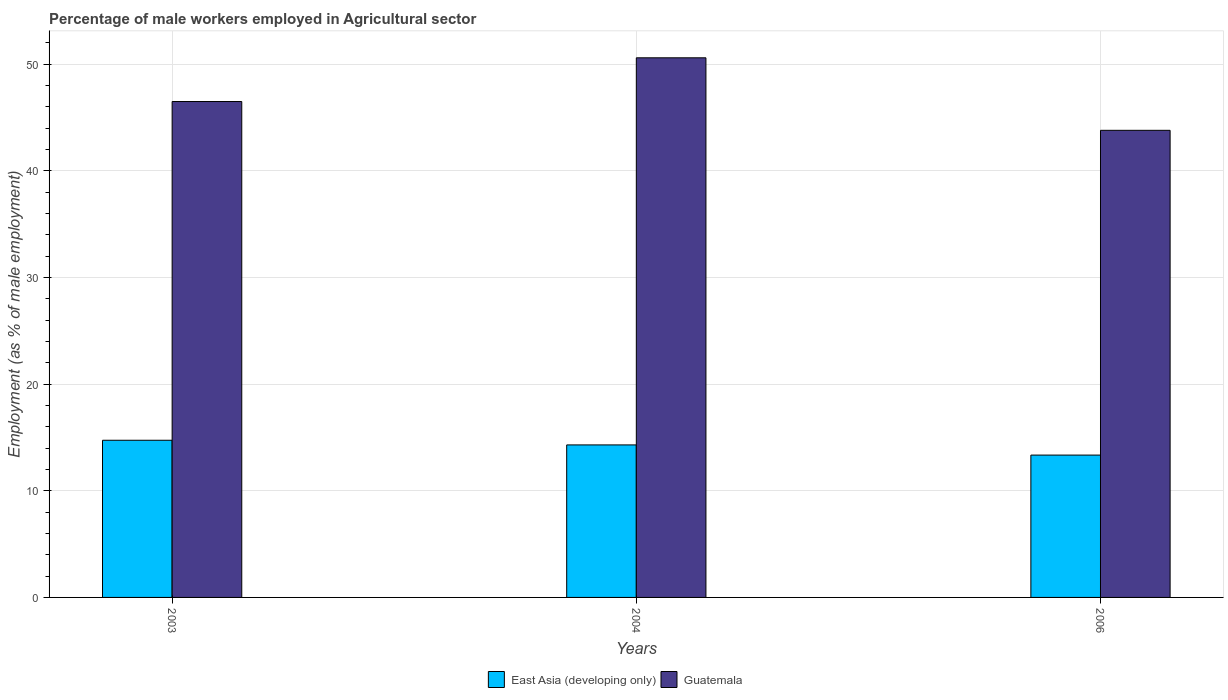How many bars are there on the 1st tick from the right?
Make the answer very short. 2. In how many cases, is the number of bars for a given year not equal to the number of legend labels?
Ensure brevity in your answer.  0. What is the percentage of male workers employed in Agricultural sector in Guatemala in 2003?
Ensure brevity in your answer.  46.5. Across all years, what is the maximum percentage of male workers employed in Agricultural sector in Guatemala?
Give a very brief answer. 50.6. Across all years, what is the minimum percentage of male workers employed in Agricultural sector in Guatemala?
Your answer should be very brief. 43.8. In which year was the percentage of male workers employed in Agricultural sector in Guatemala minimum?
Your answer should be compact. 2006. What is the total percentage of male workers employed in Agricultural sector in East Asia (developing only) in the graph?
Offer a very short reply. 42.39. What is the difference between the percentage of male workers employed in Agricultural sector in Guatemala in 2004 and that in 2006?
Provide a succinct answer. 6.8. What is the difference between the percentage of male workers employed in Agricultural sector in Guatemala in 2003 and the percentage of male workers employed in Agricultural sector in East Asia (developing only) in 2006?
Your response must be concise. 33.15. What is the average percentage of male workers employed in Agricultural sector in Guatemala per year?
Make the answer very short. 46.97. In the year 2006, what is the difference between the percentage of male workers employed in Agricultural sector in East Asia (developing only) and percentage of male workers employed in Agricultural sector in Guatemala?
Give a very brief answer. -30.45. What is the ratio of the percentage of male workers employed in Agricultural sector in East Asia (developing only) in 2003 to that in 2004?
Provide a succinct answer. 1.03. What is the difference between the highest and the second highest percentage of male workers employed in Agricultural sector in East Asia (developing only)?
Your response must be concise. 0.44. What is the difference between the highest and the lowest percentage of male workers employed in Agricultural sector in Guatemala?
Give a very brief answer. 6.8. In how many years, is the percentage of male workers employed in Agricultural sector in East Asia (developing only) greater than the average percentage of male workers employed in Agricultural sector in East Asia (developing only) taken over all years?
Give a very brief answer. 2. Is the sum of the percentage of male workers employed in Agricultural sector in East Asia (developing only) in 2004 and 2006 greater than the maximum percentage of male workers employed in Agricultural sector in Guatemala across all years?
Your answer should be very brief. No. What does the 2nd bar from the left in 2006 represents?
Keep it short and to the point. Guatemala. What does the 1st bar from the right in 2006 represents?
Your answer should be very brief. Guatemala. How many years are there in the graph?
Ensure brevity in your answer.  3. What is the difference between two consecutive major ticks on the Y-axis?
Offer a terse response. 10. Does the graph contain grids?
Ensure brevity in your answer.  Yes. How are the legend labels stacked?
Your answer should be compact. Horizontal. What is the title of the graph?
Keep it short and to the point. Percentage of male workers employed in Agricultural sector. Does "Nigeria" appear as one of the legend labels in the graph?
Your response must be concise. No. What is the label or title of the X-axis?
Provide a short and direct response. Years. What is the label or title of the Y-axis?
Make the answer very short. Employment (as % of male employment). What is the Employment (as % of male employment) in East Asia (developing only) in 2003?
Give a very brief answer. 14.74. What is the Employment (as % of male employment) in Guatemala in 2003?
Ensure brevity in your answer.  46.5. What is the Employment (as % of male employment) in East Asia (developing only) in 2004?
Offer a very short reply. 14.3. What is the Employment (as % of male employment) of Guatemala in 2004?
Your answer should be very brief. 50.6. What is the Employment (as % of male employment) in East Asia (developing only) in 2006?
Make the answer very short. 13.35. What is the Employment (as % of male employment) in Guatemala in 2006?
Give a very brief answer. 43.8. Across all years, what is the maximum Employment (as % of male employment) in East Asia (developing only)?
Your answer should be compact. 14.74. Across all years, what is the maximum Employment (as % of male employment) in Guatemala?
Provide a short and direct response. 50.6. Across all years, what is the minimum Employment (as % of male employment) of East Asia (developing only)?
Provide a succinct answer. 13.35. Across all years, what is the minimum Employment (as % of male employment) in Guatemala?
Your response must be concise. 43.8. What is the total Employment (as % of male employment) in East Asia (developing only) in the graph?
Give a very brief answer. 42.39. What is the total Employment (as % of male employment) of Guatemala in the graph?
Provide a succinct answer. 140.9. What is the difference between the Employment (as % of male employment) of East Asia (developing only) in 2003 and that in 2004?
Provide a succinct answer. 0.44. What is the difference between the Employment (as % of male employment) in East Asia (developing only) in 2003 and that in 2006?
Your answer should be compact. 1.39. What is the difference between the Employment (as % of male employment) in East Asia (developing only) in 2004 and that in 2006?
Your answer should be compact. 0.95. What is the difference between the Employment (as % of male employment) in East Asia (developing only) in 2003 and the Employment (as % of male employment) in Guatemala in 2004?
Offer a terse response. -35.86. What is the difference between the Employment (as % of male employment) of East Asia (developing only) in 2003 and the Employment (as % of male employment) of Guatemala in 2006?
Provide a succinct answer. -29.06. What is the difference between the Employment (as % of male employment) of East Asia (developing only) in 2004 and the Employment (as % of male employment) of Guatemala in 2006?
Give a very brief answer. -29.5. What is the average Employment (as % of male employment) in East Asia (developing only) per year?
Offer a terse response. 14.13. What is the average Employment (as % of male employment) of Guatemala per year?
Provide a succinct answer. 46.97. In the year 2003, what is the difference between the Employment (as % of male employment) in East Asia (developing only) and Employment (as % of male employment) in Guatemala?
Your answer should be compact. -31.76. In the year 2004, what is the difference between the Employment (as % of male employment) in East Asia (developing only) and Employment (as % of male employment) in Guatemala?
Provide a succinct answer. -36.3. In the year 2006, what is the difference between the Employment (as % of male employment) in East Asia (developing only) and Employment (as % of male employment) in Guatemala?
Ensure brevity in your answer.  -30.45. What is the ratio of the Employment (as % of male employment) of East Asia (developing only) in 2003 to that in 2004?
Give a very brief answer. 1.03. What is the ratio of the Employment (as % of male employment) in Guatemala in 2003 to that in 2004?
Make the answer very short. 0.92. What is the ratio of the Employment (as % of male employment) of East Asia (developing only) in 2003 to that in 2006?
Ensure brevity in your answer.  1.1. What is the ratio of the Employment (as % of male employment) of Guatemala in 2003 to that in 2006?
Keep it short and to the point. 1.06. What is the ratio of the Employment (as % of male employment) in East Asia (developing only) in 2004 to that in 2006?
Make the answer very short. 1.07. What is the ratio of the Employment (as % of male employment) of Guatemala in 2004 to that in 2006?
Offer a very short reply. 1.16. What is the difference between the highest and the second highest Employment (as % of male employment) of East Asia (developing only)?
Give a very brief answer. 0.44. What is the difference between the highest and the lowest Employment (as % of male employment) in East Asia (developing only)?
Provide a succinct answer. 1.39. What is the difference between the highest and the lowest Employment (as % of male employment) of Guatemala?
Ensure brevity in your answer.  6.8. 